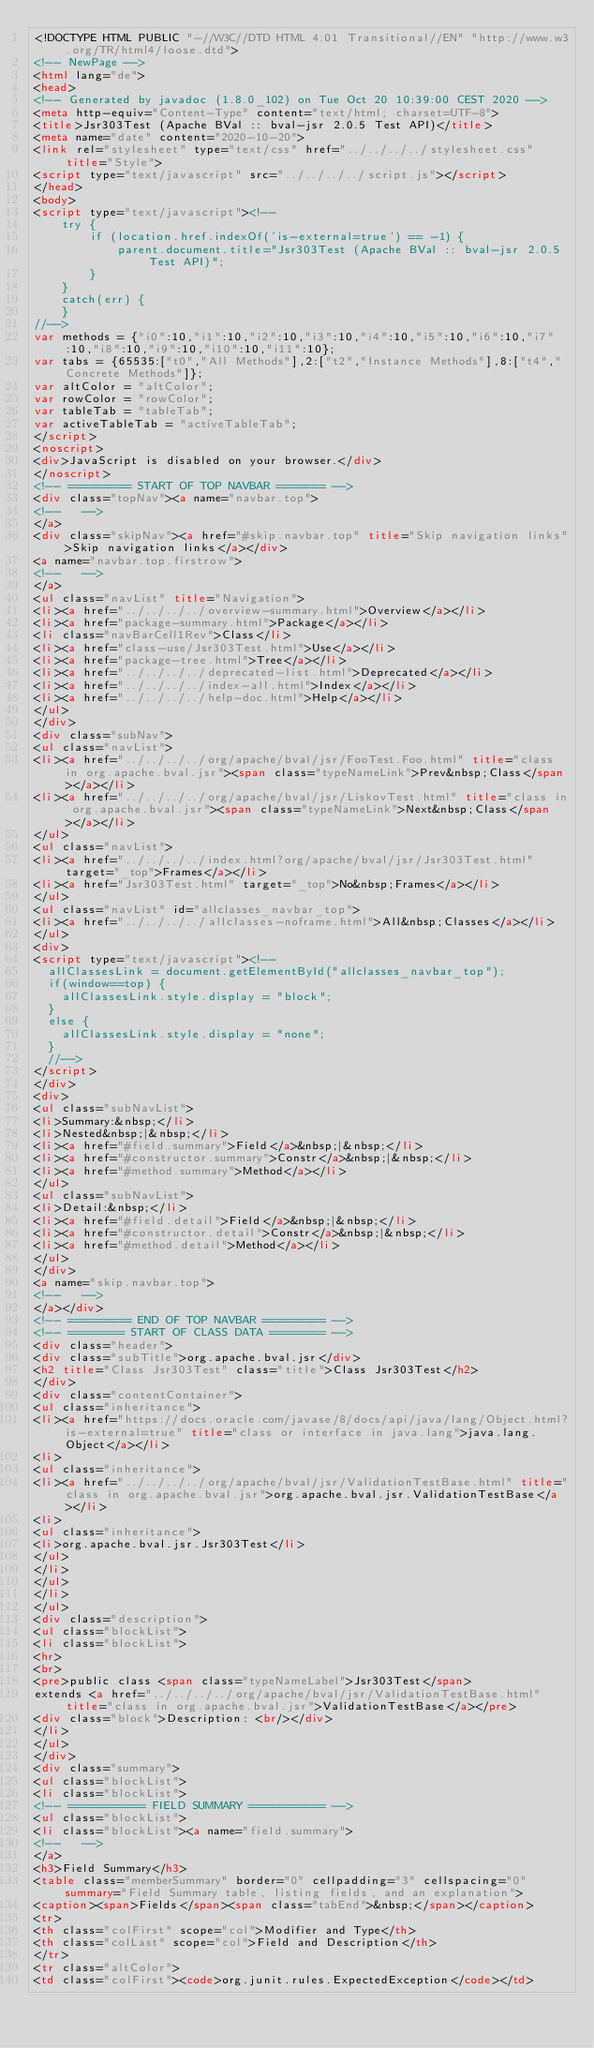Convert code to text. <code><loc_0><loc_0><loc_500><loc_500><_HTML_><!DOCTYPE HTML PUBLIC "-//W3C//DTD HTML 4.01 Transitional//EN" "http://www.w3.org/TR/html4/loose.dtd">
<!-- NewPage -->
<html lang="de">
<head>
<!-- Generated by javadoc (1.8.0_102) on Tue Oct 20 10:39:00 CEST 2020 -->
<meta http-equiv="Content-Type" content="text/html; charset=UTF-8">
<title>Jsr303Test (Apache BVal :: bval-jsr 2.0.5 Test API)</title>
<meta name="date" content="2020-10-20">
<link rel="stylesheet" type="text/css" href="../../../../stylesheet.css" title="Style">
<script type="text/javascript" src="../../../../script.js"></script>
</head>
<body>
<script type="text/javascript"><!--
    try {
        if (location.href.indexOf('is-external=true') == -1) {
            parent.document.title="Jsr303Test (Apache BVal :: bval-jsr 2.0.5 Test API)";
        }
    }
    catch(err) {
    }
//-->
var methods = {"i0":10,"i1":10,"i2":10,"i3":10,"i4":10,"i5":10,"i6":10,"i7":10,"i8":10,"i9":10,"i10":10,"i11":10};
var tabs = {65535:["t0","All Methods"],2:["t2","Instance Methods"],8:["t4","Concrete Methods"]};
var altColor = "altColor";
var rowColor = "rowColor";
var tableTab = "tableTab";
var activeTableTab = "activeTableTab";
</script>
<noscript>
<div>JavaScript is disabled on your browser.</div>
</noscript>
<!-- ========= START OF TOP NAVBAR ======= -->
<div class="topNav"><a name="navbar.top">
<!--   -->
</a>
<div class="skipNav"><a href="#skip.navbar.top" title="Skip navigation links">Skip navigation links</a></div>
<a name="navbar.top.firstrow">
<!--   -->
</a>
<ul class="navList" title="Navigation">
<li><a href="../../../../overview-summary.html">Overview</a></li>
<li><a href="package-summary.html">Package</a></li>
<li class="navBarCell1Rev">Class</li>
<li><a href="class-use/Jsr303Test.html">Use</a></li>
<li><a href="package-tree.html">Tree</a></li>
<li><a href="../../../../deprecated-list.html">Deprecated</a></li>
<li><a href="../../../../index-all.html">Index</a></li>
<li><a href="../../../../help-doc.html">Help</a></li>
</ul>
</div>
<div class="subNav">
<ul class="navList">
<li><a href="../../../../org/apache/bval/jsr/FooTest.Foo.html" title="class in org.apache.bval.jsr"><span class="typeNameLink">Prev&nbsp;Class</span></a></li>
<li><a href="../../../../org/apache/bval/jsr/LiskovTest.html" title="class in org.apache.bval.jsr"><span class="typeNameLink">Next&nbsp;Class</span></a></li>
</ul>
<ul class="navList">
<li><a href="../../../../index.html?org/apache/bval/jsr/Jsr303Test.html" target="_top">Frames</a></li>
<li><a href="Jsr303Test.html" target="_top">No&nbsp;Frames</a></li>
</ul>
<ul class="navList" id="allclasses_navbar_top">
<li><a href="../../../../allclasses-noframe.html">All&nbsp;Classes</a></li>
</ul>
<div>
<script type="text/javascript"><!--
  allClassesLink = document.getElementById("allclasses_navbar_top");
  if(window==top) {
    allClassesLink.style.display = "block";
  }
  else {
    allClassesLink.style.display = "none";
  }
  //-->
</script>
</div>
<div>
<ul class="subNavList">
<li>Summary:&nbsp;</li>
<li>Nested&nbsp;|&nbsp;</li>
<li><a href="#field.summary">Field</a>&nbsp;|&nbsp;</li>
<li><a href="#constructor.summary">Constr</a>&nbsp;|&nbsp;</li>
<li><a href="#method.summary">Method</a></li>
</ul>
<ul class="subNavList">
<li>Detail:&nbsp;</li>
<li><a href="#field.detail">Field</a>&nbsp;|&nbsp;</li>
<li><a href="#constructor.detail">Constr</a>&nbsp;|&nbsp;</li>
<li><a href="#method.detail">Method</a></li>
</ul>
</div>
<a name="skip.navbar.top">
<!--   -->
</a></div>
<!-- ========= END OF TOP NAVBAR ========= -->
<!-- ======== START OF CLASS DATA ======== -->
<div class="header">
<div class="subTitle">org.apache.bval.jsr</div>
<h2 title="Class Jsr303Test" class="title">Class Jsr303Test</h2>
</div>
<div class="contentContainer">
<ul class="inheritance">
<li><a href="https://docs.oracle.com/javase/8/docs/api/java/lang/Object.html?is-external=true" title="class or interface in java.lang">java.lang.Object</a></li>
<li>
<ul class="inheritance">
<li><a href="../../../../org/apache/bval/jsr/ValidationTestBase.html" title="class in org.apache.bval.jsr">org.apache.bval.jsr.ValidationTestBase</a></li>
<li>
<ul class="inheritance">
<li>org.apache.bval.jsr.Jsr303Test</li>
</ul>
</li>
</ul>
</li>
</ul>
<div class="description">
<ul class="blockList">
<li class="blockList">
<hr>
<br>
<pre>public class <span class="typeNameLabel">Jsr303Test</span>
extends <a href="../../../../org/apache/bval/jsr/ValidationTestBase.html" title="class in org.apache.bval.jsr">ValidationTestBase</a></pre>
<div class="block">Description: <br/></div>
</li>
</ul>
</div>
<div class="summary">
<ul class="blockList">
<li class="blockList">
<!-- =========== FIELD SUMMARY =========== -->
<ul class="blockList">
<li class="blockList"><a name="field.summary">
<!--   -->
</a>
<h3>Field Summary</h3>
<table class="memberSummary" border="0" cellpadding="3" cellspacing="0" summary="Field Summary table, listing fields, and an explanation">
<caption><span>Fields</span><span class="tabEnd">&nbsp;</span></caption>
<tr>
<th class="colFirst" scope="col">Modifier and Type</th>
<th class="colLast" scope="col">Field and Description</th>
</tr>
<tr class="altColor">
<td class="colFirst"><code>org.junit.rules.ExpectedException</code></td></code> 